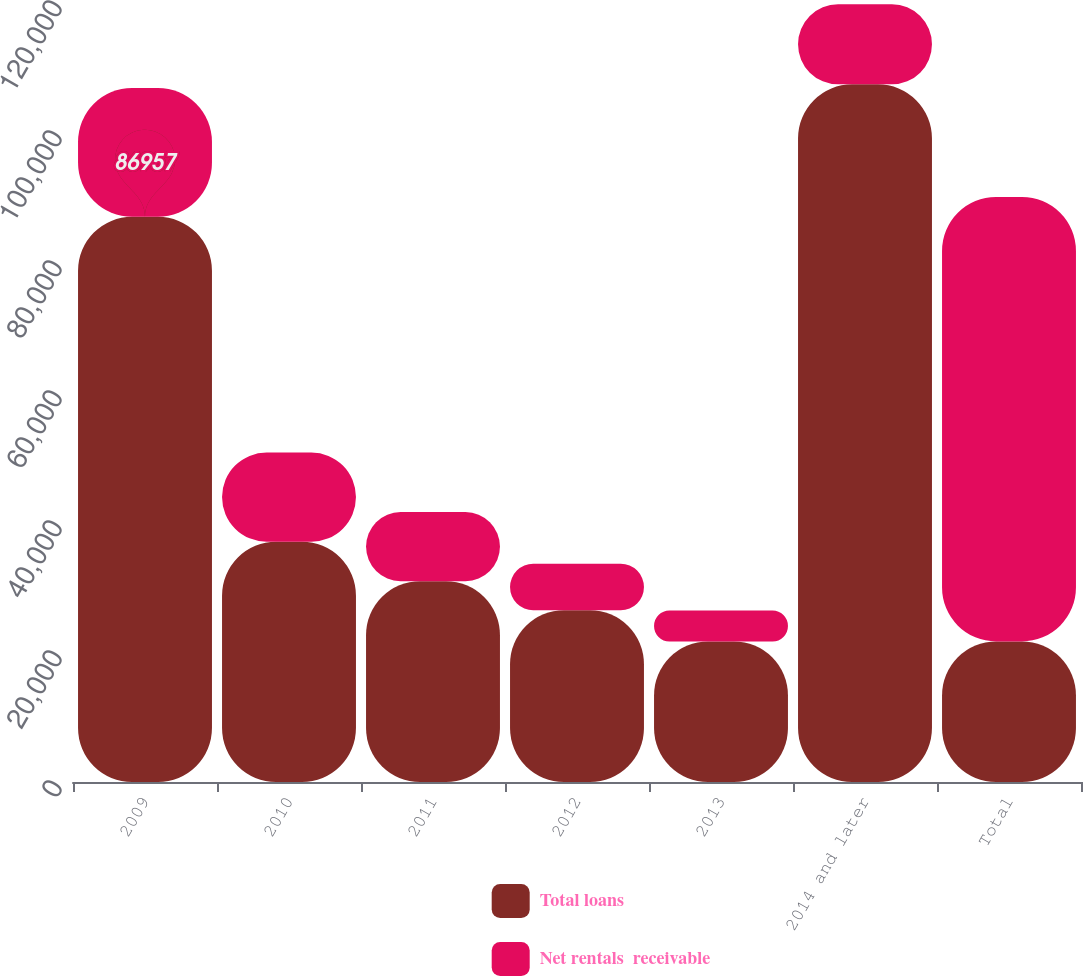<chart> <loc_0><loc_0><loc_500><loc_500><stacked_bar_chart><ecel><fcel>2009<fcel>2010<fcel>2011<fcel>2012<fcel>2013<fcel>2014 and later<fcel>Total<nl><fcel>Total loans<fcel>86957<fcel>36970<fcel>30902<fcel>26421<fcel>21624<fcel>107329<fcel>21624<nl><fcel>Net rentals  receivable<fcel>19819<fcel>13725<fcel>10624<fcel>7150<fcel>4752<fcel>12325<fcel>68395<nl></chart> 